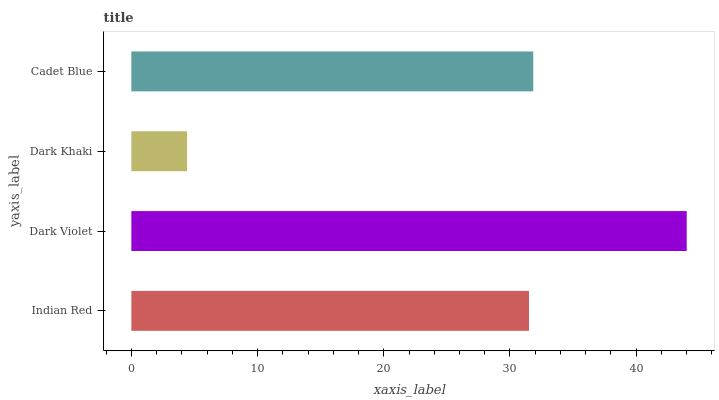Is Dark Khaki the minimum?
Answer yes or no. Yes. Is Dark Violet the maximum?
Answer yes or no. Yes. Is Dark Violet the minimum?
Answer yes or no. No. Is Dark Khaki the maximum?
Answer yes or no. No. Is Dark Violet greater than Dark Khaki?
Answer yes or no. Yes. Is Dark Khaki less than Dark Violet?
Answer yes or no. Yes. Is Dark Khaki greater than Dark Violet?
Answer yes or no. No. Is Dark Violet less than Dark Khaki?
Answer yes or no. No. Is Cadet Blue the high median?
Answer yes or no. Yes. Is Indian Red the low median?
Answer yes or no. Yes. Is Indian Red the high median?
Answer yes or no. No. Is Cadet Blue the low median?
Answer yes or no. No. 